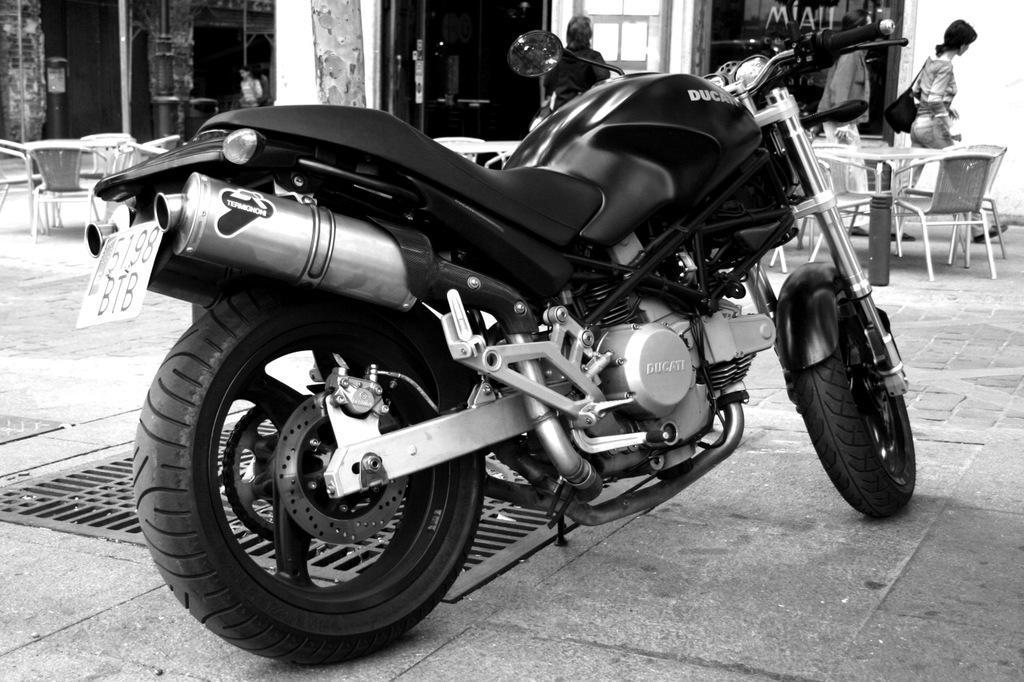In one or two sentences, can you explain what this image depicts? In the picture there is a bike on the floor near to the bike there are some chairs there are persons walking in chairs and tables. 